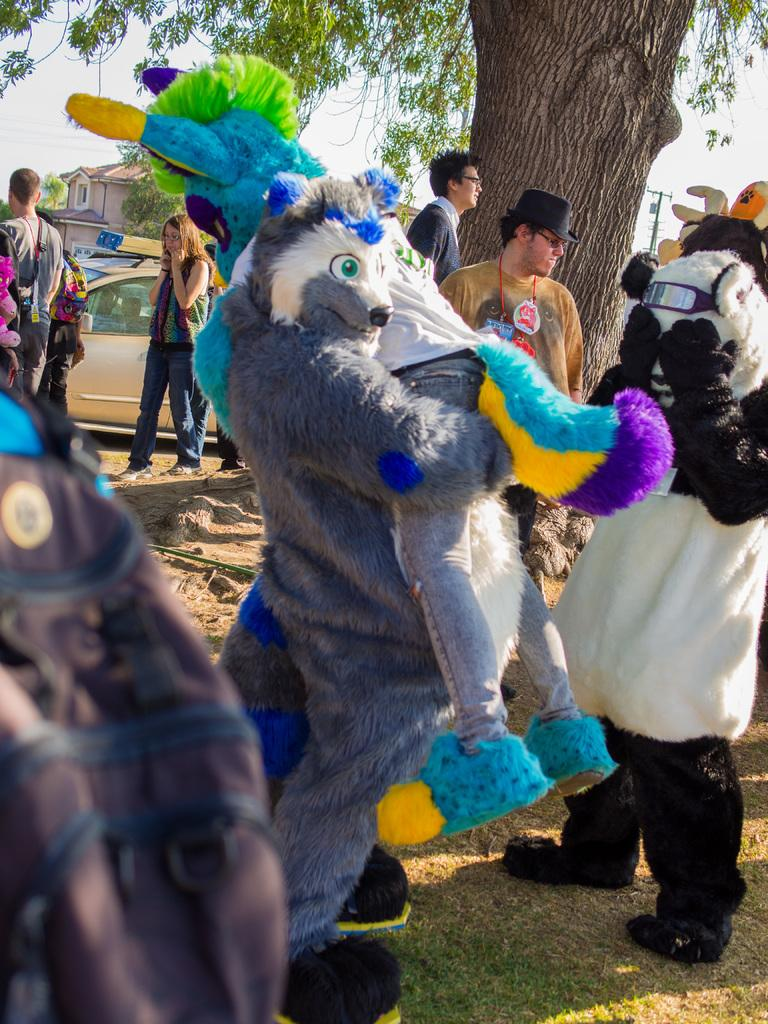What are the people in the image doing? The people in the image are standing beneath a tree. Can you describe the attire of some of the people in the image? Some people in the image are in different costumes. What can be seen in the background of the image? There is a car, a building, trees, and the sky visible in the background of the image. What type of joke is being told by the elbow in the image? There is no elbow present in the image, and therefore no joke can be attributed to it. 